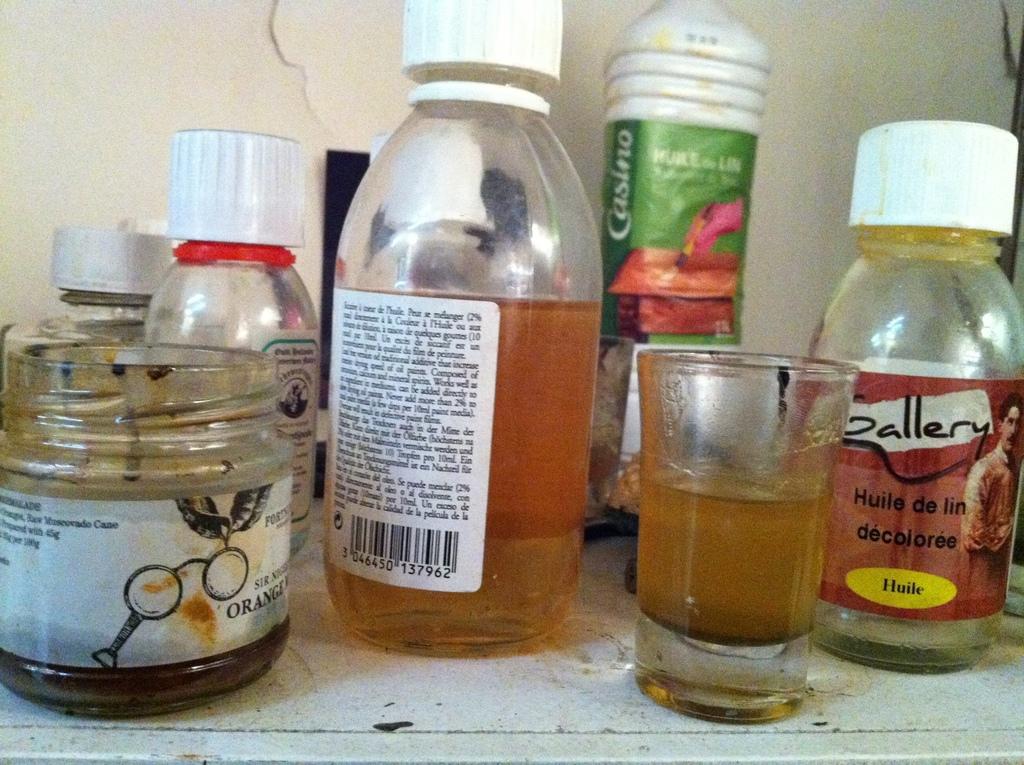What is the name of the bottled liquid on the right?
Your answer should be very brief. Gallery. 